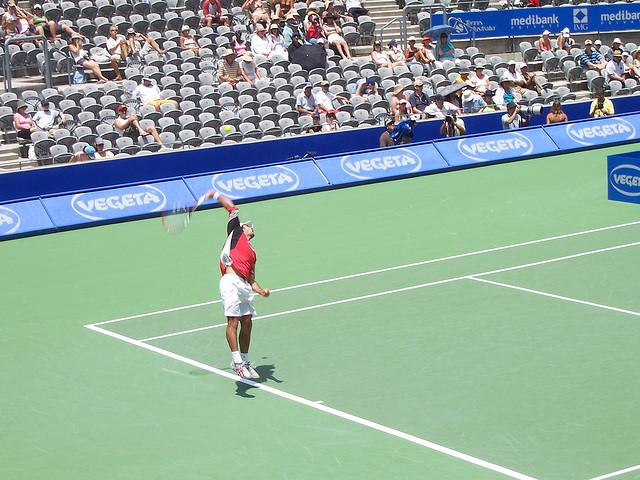What is the brand advertising along the sides of the court? Please explain your reasoning. condiment. It is a seasoning put on foods 